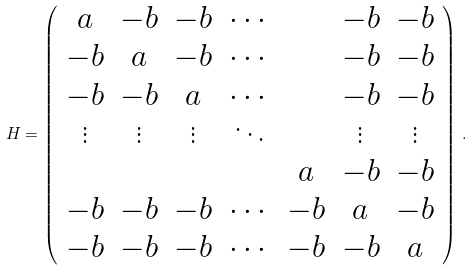<formula> <loc_0><loc_0><loc_500><loc_500>H = \left ( \begin{array} { c c c c c c c } a & - b & - b & \cdots & & - b & - b \\ - b & a & - b & \cdots & & - b & - b \\ - b & - b & a & \cdots & & - b & - b \\ \vdots & \vdots & \vdots & \ddots & & \vdots & \vdots \\ & & & & a & - b & - b \\ - b & - b & - b & \cdots & - b & a & - b \\ - b & - b & - b & \cdots & - b & - b & a \end{array} \right ) \, .</formula> 